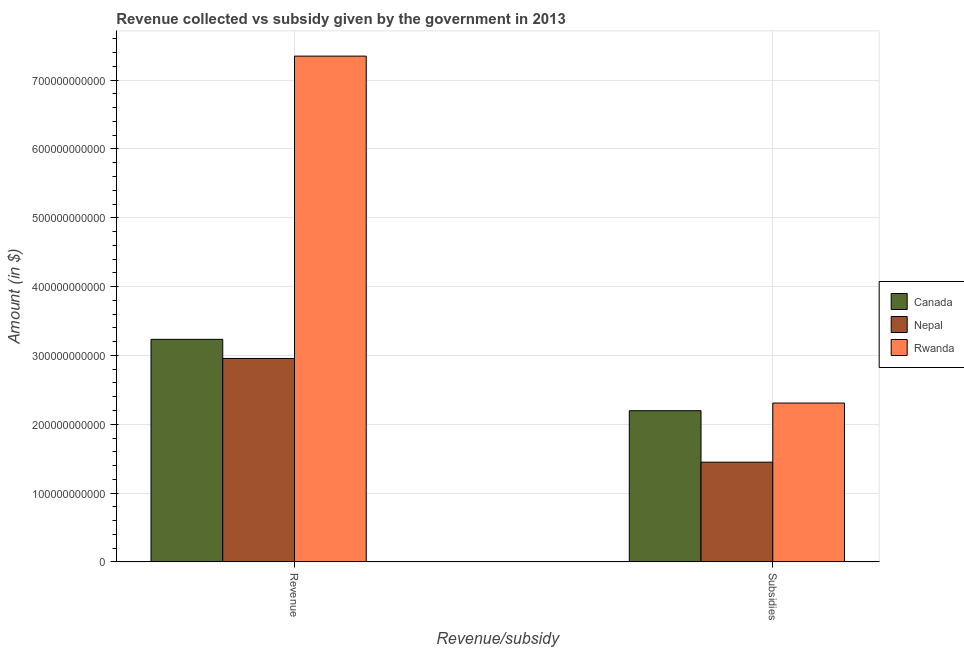How many groups of bars are there?
Your answer should be very brief. 2. How many bars are there on the 1st tick from the left?
Your response must be concise. 3. What is the label of the 2nd group of bars from the left?
Your answer should be very brief. Subsidies. What is the amount of subsidies given in Canada?
Keep it short and to the point. 2.20e+11. Across all countries, what is the maximum amount of revenue collected?
Offer a terse response. 7.35e+11. Across all countries, what is the minimum amount of revenue collected?
Your answer should be compact. 2.96e+11. In which country was the amount of revenue collected maximum?
Your answer should be compact. Rwanda. In which country was the amount of subsidies given minimum?
Keep it short and to the point. Nepal. What is the total amount of subsidies given in the graph?
Offer a very short reply. 5.95e+11. What is the difference between the amount of subsidies given in Canada and that in Rwanda?
Ensure brevity in your answer.  -1.11e+1. What is the difference between the amount of subsidies given in Nepal and the amount of revenue collected in Rwanda?
Give a very brief answer. -5.90e+11. What is the average amount of revenue collected per country?
Your answer should be very brief. 4.51e+11. What is the difference between the amount of subsidies given and amount of revenue collected in Canada?
Offer a very short reply. -1.04e+11. In how many countries, is the amount of revenue collected greater than 20000000000 $?
Give a very brief answer. 3. What is the ratio of the amount of revenue collected in Nepal to that in Rwanda?
Provide a short and direct response. 0.4. Is the amount of revenue collected in Rwanda less than that in Nepal?
Your response must be concise. No. In how many countries, is the amount of subsidies given greater than the average amount of subsidies given taken over all countries?
Provide a short and direct response. 2. What does the 1st bar from the left in Subsidies represents?
Ensure brevity in your answer.  Canada. Are all the bars in the graph horizontal?
Offer a very short reply. No. What is the difference between two consecutive major ticks on the Y-axis?
Keep it short and to the point. 1.00e+11. Does the graph contain grids?
Give a very brief answer. Yes. How many legend labels are there?
Give a very brief answer. 3. What is the title of the graph?
Keep it short and to the point. Revenue collected vs subsidy given by the government in 2013. What is the label or title of the X-axis?
Offer a terse response. Revenue/subsidy. What is the label or title of the Y-axis?
Keep it short and to the point. Amount (in $). What is the Amount (in $) in Canada in Revenue?
Make the answer very short. 3.23e+11. What is the Amount (in $) in Nepal in Revenue?
Provide a succinct answer. 2.96e+11. What is the Amount (in $) in Rwanda in Revenue?
Your answer should be very brief. 7.35e+11. What is the Amount (in $) of Canada in Subsidies?
Keep it short and to the point. 2.20e+11. What is the Amount (in $) in Nepal in Subsidies?
Keep it short and to the point. 1.45e+11. What is the Amount (in $) in Rwanda in Subsidies?
Your answer should be compact. 2.31e+11. Across all Revenue/subsidy, what is the maximum Amount (in $) of Canada?
Give a very brief answer. 3.23e+11. Across all Revenue/subsidy, what is the maximum Amount (in $) in Nepal?
Ensure brevity in your answer.  2.96e+11. Across all Revenue/subsidy, what is the maximum Amount (in $) of Rwanda?
Give a very brief answer. 7.35e+11. Across all Revenue/subsidy, what is the minimum Amount (in $) in Canada?
Your answer should be compact. 2.20e+11. Across all Revenue/subsidy, what is the minimum Amount (in $) of Nepal?
Your answer should be compact. 1.45e+11. Across all Revenue/subsidy, what is the minimum Amount (in $) of Rwanda?
Keep it short and to the point. 2.31e+11. What is the total Amount (in $) in Canada in the graph?
Offer a very short reply. 5.43e+11. What is the total Amount (in $) in Nepal in the graph?
Your response must be concise. 4.40e+11. What is the total Amount (in $) in Rwanda in the graph?
Keep it short and to the point. 9.66e+11. What is the difference between the Amount (in $) of Canada in Revenue and that in Subsidies?
Your response must be concise. 1.04e+11. What is the difference between the Amount (in $) of Nepal in Revenue and that in Subsidies?
Keep it short and to the point. 1.51e+11. What is the difference between the Amount (in $) of Rwanda in Revenue and that in Subsidies?
Your answer should be very brief. 5.04e+11. What is the difference between the Amount (in $) in Canada in Revenue and the Amount (in $) in Nepal in Subsidies?
Your answer should be compact. 1.79e+11. What is the difference between the Amount (in $) in Canada in Revenue and the Amount (in $) in Rwanda in Subsidies?
Offer a terse response. 9.26e+1. What is the difference between the Amount (in $) in Nepal in Revenue and the Amount (in $) in Rwanda in Subsidies?
Your answer should be compact. 6.48e+1. What is the average Amount (in $) in Canada per Revenue/subsidy?
Offer a very short reply. 2.72e+11. What is the average Amount (in $) of Nepal per Revenue/subsidy?
Your response must be concise. 2.20e+11. What is the average Amount (in $) in Rwanda per Revenue/subsidy?
Your response must be concise. 4.83e+11. What is the difference between the Amount (in $) of Canada and Amount (in $) of Nepal in Revenue?
Ensure brevity in your answer.  2.78e+1. What is the difference between the Amount (in $) in Canada and Amount (in $) in Rwanda in Revenue?
Provide a succinct answer. -4.12e+11. What is the difference between the Amount (in $) in Nepal and Amount (in $) in Rwanda in Revenue?
Provide a short and direct response. -4.39e+11. What is the difference between the Amount (in $) of Canada and Amount (in $) of Nepal in Subsidies?
Provide a succinct answer. 7.48e+1. What is the difference between the Amount (in $) in Canada and Amount (in $) in Rwanda in Subsidies?
Offer a terse response. -1.11e+1. What is the difference between the Amount (in $) in Nepal and Amount (in $) in Rwanda in Subsidies?
Your answer should be compact. -8.59e+1. What is the ratio of the Amount (in $) in Canada in Revenue to that in Subsidies?
Give a very brief answer. 1.47. What is the ratio of the Amount (in $) in Nepal in Revenue to that in Subsidies?
Give a very brief answer. 2.04. What is the ratio of the Amount (in $) of Rwanda in Revenue to that in Subsidies?
Provide a succinct answer. 3.18. What is the difference between the highest and the second highest Amount (in $) of Canada?
Make the answer very short. 1.04e+11. What is the difference between the highest and the second highest Amount (in $) of Nepal?
Your answer should be very brief. 1.51e+11. What is the difference between the highest and the second highest Amount (in $) of Rwanda?
Your answer should be compact. 5.04e+11. What is the difference between the highest and the lowest Amount (in $) of Canada?
Your answer should be compact. 1.04e+11. What is the difference between the highest and the lowest Amount (in $) in Nepal?
Your answer should be very brief. 1.51e+11. What is the difference between the highest and the lowest Amount (in $) in Rwanda?
Your answer should be very brief. 5.04e+11. 